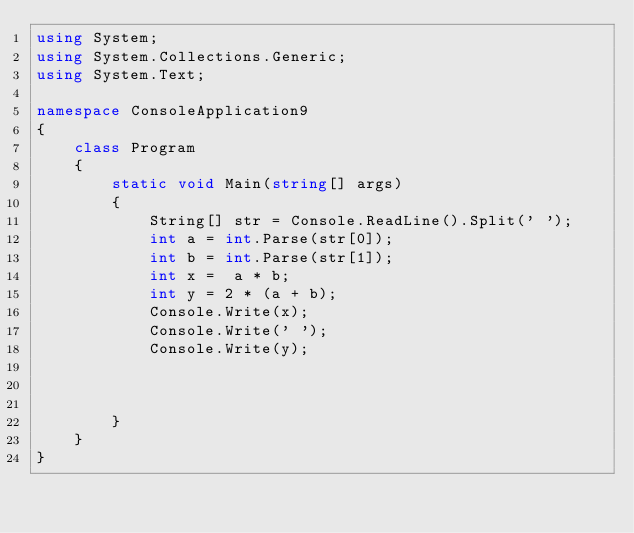<code> <loc_0><loc_0><loc_500><loc_500><_C#_>using System;
using System.Collections.Generic;
using System.Text;

namespace ConsoleApplication9
{
    class Program
    {
        static void Main(string[] args)
        {
            String[] str = Console.ReadLine().Split(' ');
            int a = int.Parse(str[0]);
            int b = int.Parse(str[1]);
            int x =  a * b;
            int y = 2 * (a + b);
            Console.Write(x);
            Console.Write(' ');
            Console.Write(y);
           
         

        }
    }
}</code> 